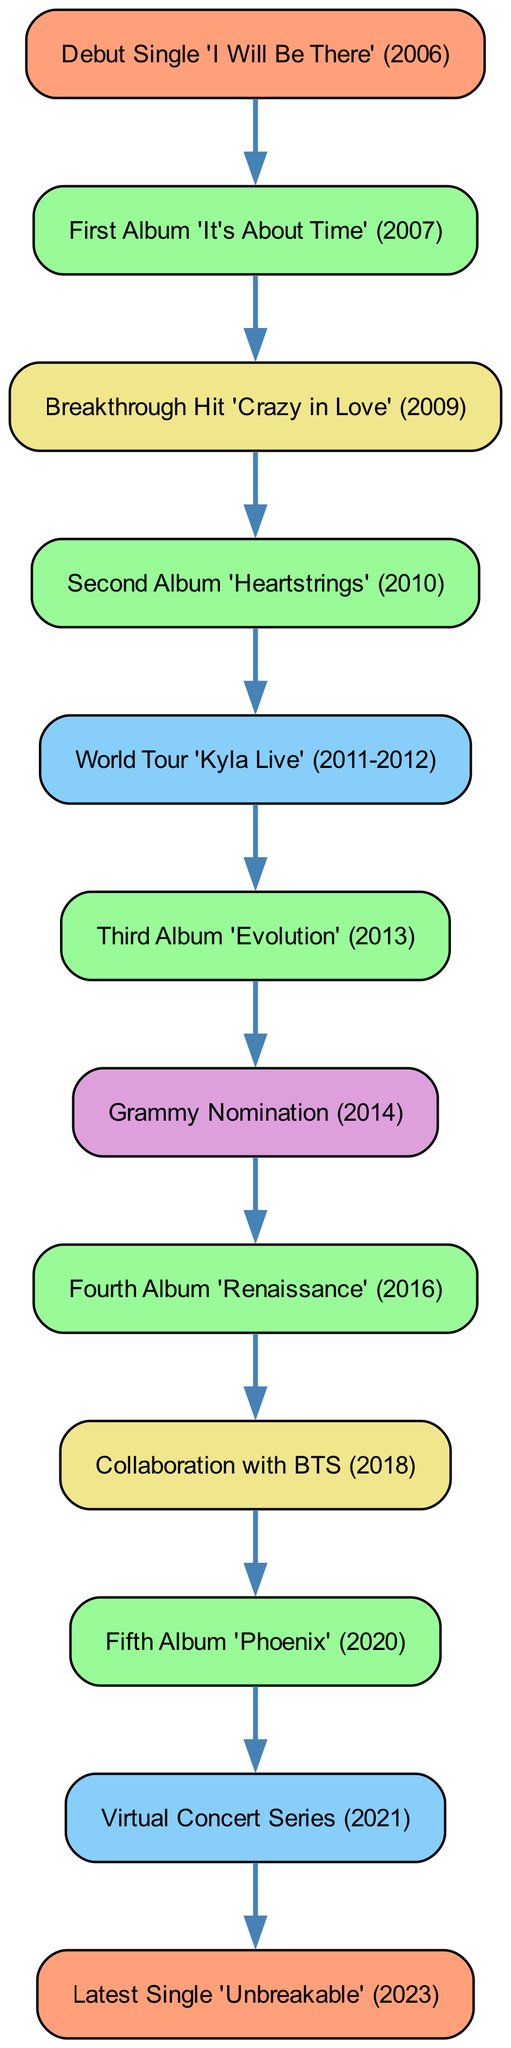What was Kyla's debut single? The diagram shows that the first node is "Debut Single 'I Will Be There' (2006)", which indicates this was her debut single.
Answer: Debut Single 'I Will Be There' (2006) How many albums has Kyla released by 2020? By following the nodes labeled as albums in the diagram, there are five albums listed: 'It's About Time' (2007), 'Heartstrings' (2010), 'Evolution' (2013), 'Renaissance' (2016), and 'Phoenix' (2020).
Answer: 5 What milestone directly follows the Third Album 'Evolution'? The diagram shows that after "Third Album 'Evolution' (2013)", the next node is "Grammy Nomination (2014)".
Answer: Grammy Nomination (2014) Which album is associated with the collaboration with BTS? In the diagram, the node "Collaboration with BTS (2018)" is directly linked as the node that follows "Fourth Album 'Renaissance' (2016)", indicating that the collaboration occurred after that album.
Answer: Fourth Album 'Renaissance' (2016) What event occurred between the Fourth Album and the Fifth Album? The diagram indicates that the "Collaboration with BTS (2018)" is the event that occurs in between the "Fourth Album 'Renaissance' (2016)" and "Fifth Album 'Phoenix' (2020)".
Answer: Collaboration with BTS (2018) What was Kyla's latest single released? The final node shown at the end of the directed graph points to "Latest Single 'Unbreakable' (2023)", indicating this is her most recent release.
Answer: Latest Single 'Unbreakable' (2023) What major event took place after the 'Kyla Live' World Tour? According to the diagram, the "Third Album 'Evolution' (2013)" followed the "World Tour 'Kyla Live' (2011-2012)", making it the major event afterward.
Answer: Third Album 'Evolution' (2013) How many nodes represent album releases in Kyla's career progression? The diagram lists five distinct album nodes: 'It's About Time', 'Heartstrings', 'Evolution', 'Renaissance', and 'Phoenix', totaling five album nodes in the graph.
Answer: 5 Which year did Kyla have her Grammy nomination? The node "Grammy Nomination (2014)" indicates that this milestone occurred in the year 2014.
Answer: 2014 